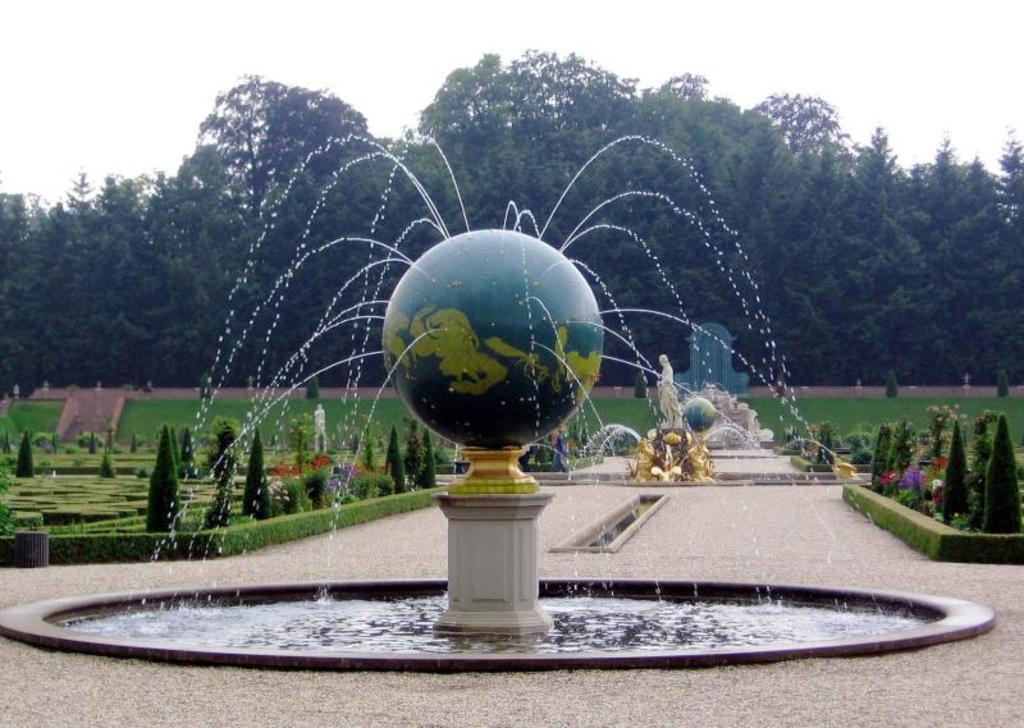What is the main feature in the front portion of the image? There is a water fountain in the front portion of the image. What types of vegetation can be seen in the background of the image? There are plants, bushes, grass, and trees in the background of the image. What other structures or features are present in the background of the image? There are statues, additional water fountains, and an arch in the background of the image. What part of the natural environment is visible in the background of the image? The sky is visible in the background of the image. What type of mailbox can be seen in the image? There is no mailbox present in the image. What relation does the person in the image have with the statues in the background? There is no person present in the image, so it is impossible to determine any relation with the statues. 